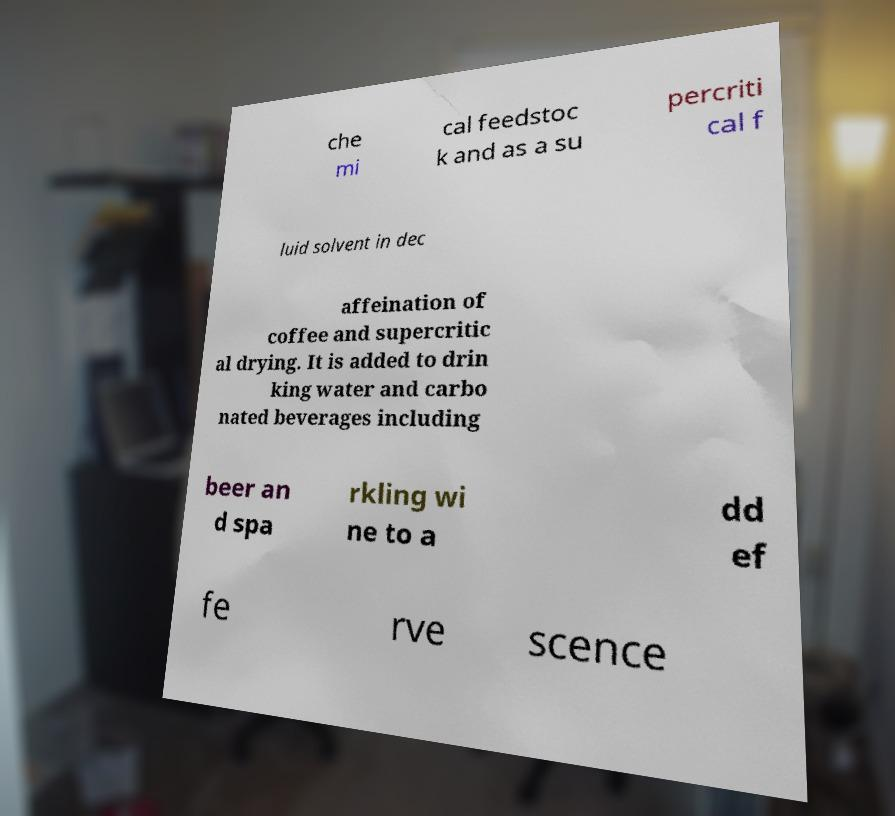Could you extract and type out the text from this image? che mi cal feedstoc k and as a su percriti cal f luid solvent in dec affeination of coffee and supercritic al drying. It is added to drin king water and carbo nated beverages including beer an d spa rkling wi ne to a dd ef fe rve scence 